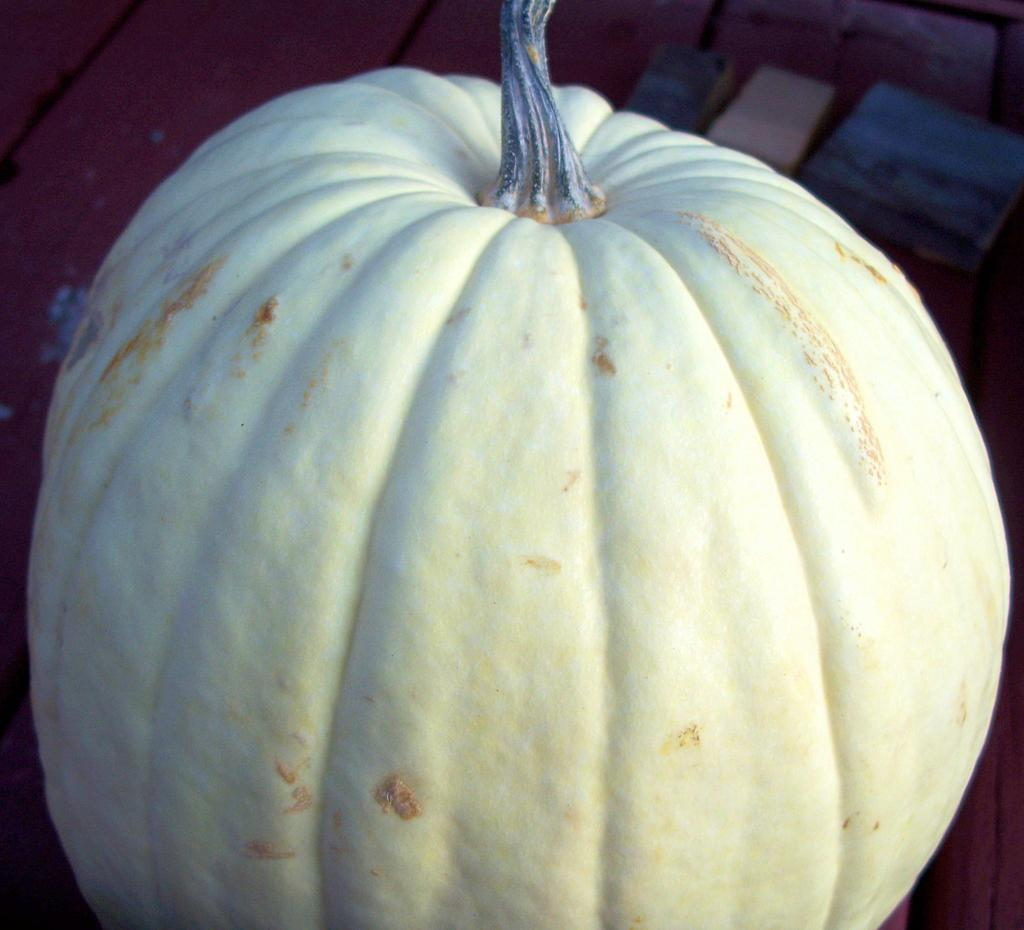What is the main object in the image? There is a pumpkin in the image. Is the pumpkin placed on any surface or object? Yes, the pumpkin is on an object. What type of rhythm can be heard coming from the pumpkin in the image? There is no indication of sound or rhythm in the image, as it features a pumpkin on an object. 